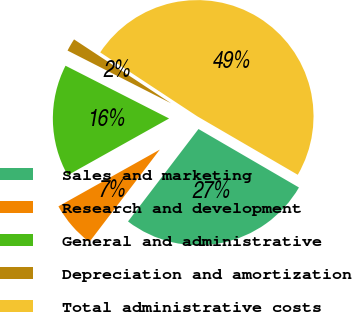<chart> <loc_0><loc_0><loc_500><loc_500><pie_chart><fcel>Sales and marketing<fcel>Research and development<fcel>General and administrative<fcel>Depreciation and amortization<fcel>Total administrative costs<nl><fcel>26.98%<fcel>6.51%<fcel>15.62%<fcel>1.77%<fcel>49.12%<nl></chart> 